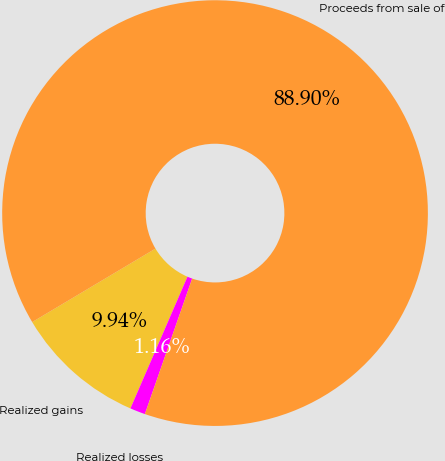Convert chart to OTSL. <chart><loc_0><loc_0><loc_500><loc_500><pie_chart><fcel>Realized gains<fcel>Realized losses<fcel>Proceeds from sale of<nl><fcel>9.94%<fcel>1.16%<fcel>88.9%<nl></chart> 